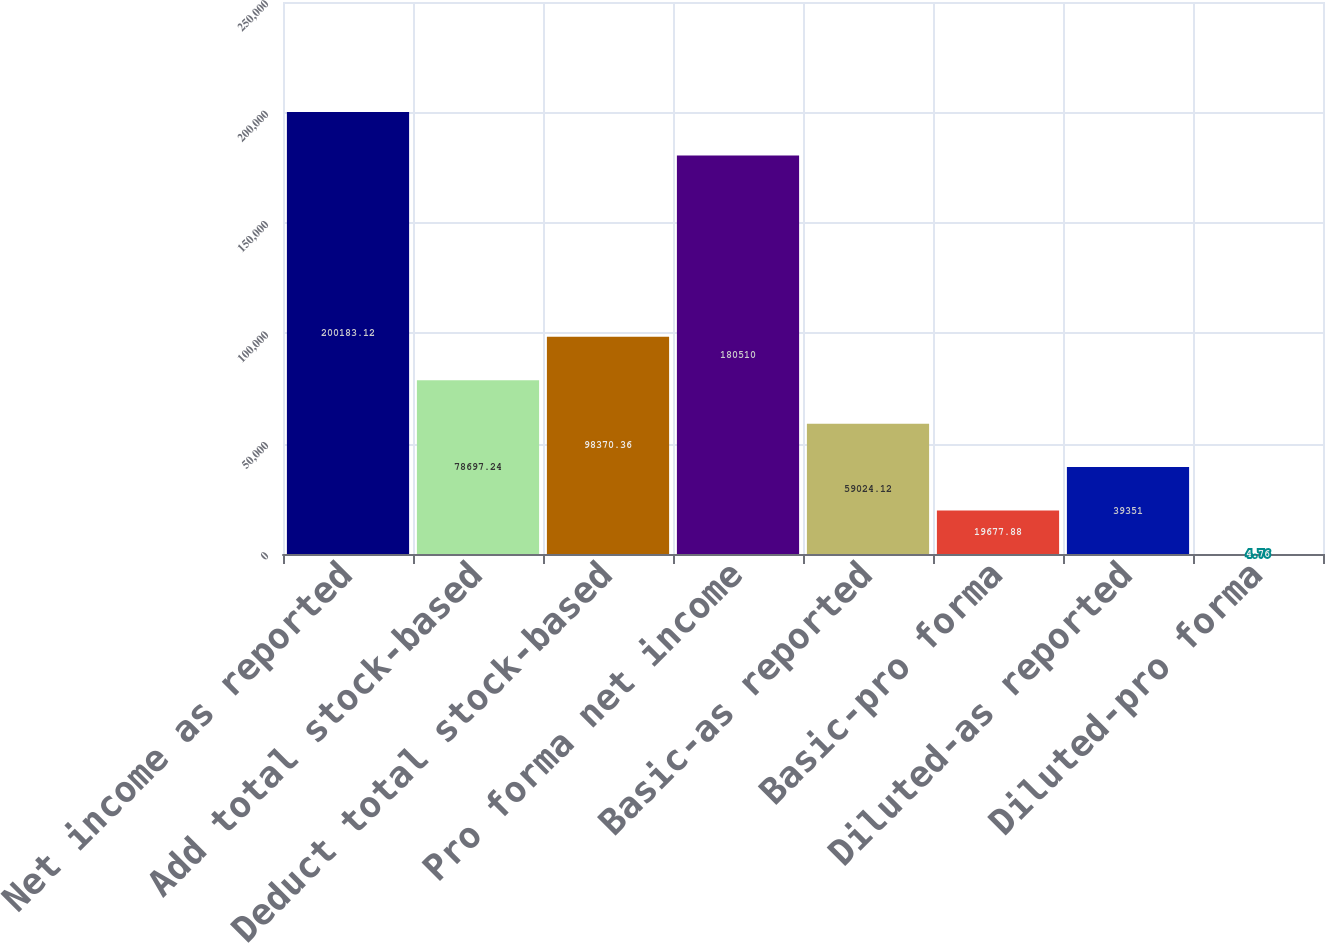<chart> <loc_0><loc_0><loc_500><loc_500><bar_chart><fcel>Net income as reported<fcel>Add total stock-based<fcel>Deduct total stock-based<fcel>Pro forma net income<fcel>Basic-as reported<fcel>Basic-pro forma<fcel>Diluted-as reported<fcel>Diluted-pro forma<nl><fcel>200183<fcel>78697.2<fcel>98370.4<fcel>180510<fcel>59024.1<fcel>19677.9<fcel>39351<fcel>4.76<nl></chart> 